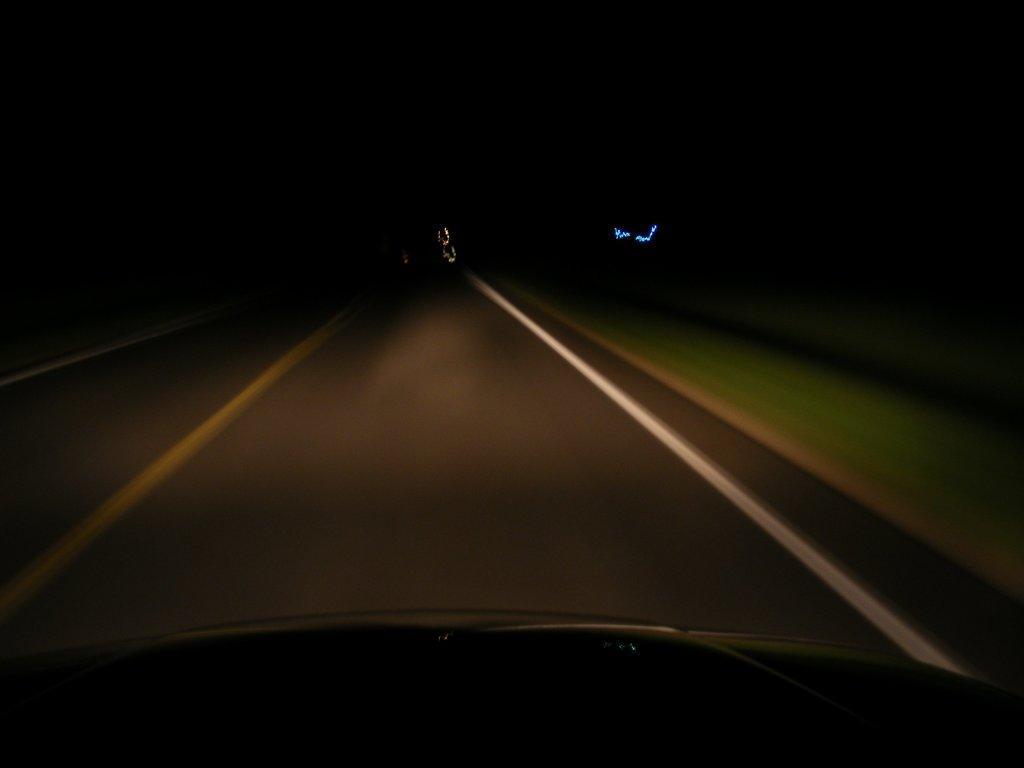In one or two sentences, can you explain what this image depicts? Here in this picture we can see a road present and on the side of it we can see the ground is covered with grass and this view is seen through a car present on the road over there. 